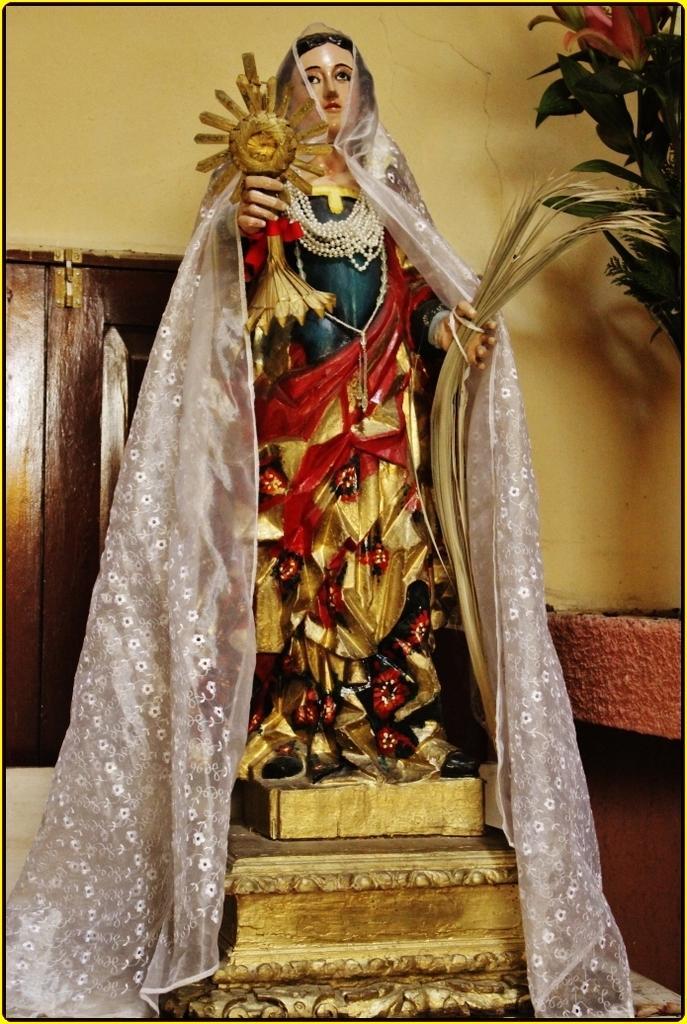Please provide a concise description of this image. This picture shows a statue and a cloth on it and we see a plant on the side and a window on the back. 